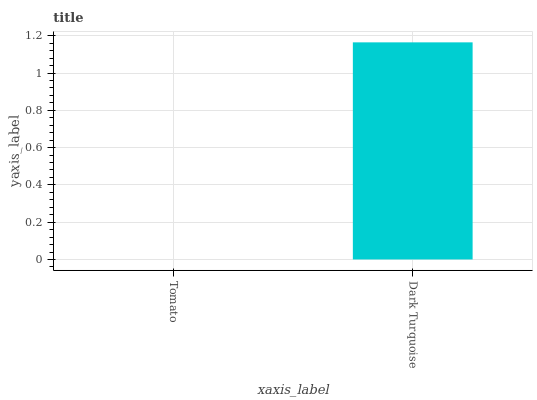Is Tomato the minimum?
Answer yes or no. Yes. Is Dark Turquoise the maximum?
Answer yes or no. Yes. Is Dark Turquoise the minimum?
Answer yes or no. No. Is Dark Turquoise greater than Tomato?
Answer yes or no. Yes. Is Tomato less than Dark Turquoise?
Answer yes or no. Yes. Is Tomato greater than Dark Turquoise?
Answer yes or no. No. Is Dark Turquoise less than Tomato?
Answer yes or no. No. Is Dark Turquoise the high median?
Answer yes or no. Yes. Is Tomato the low median?
Answer yes or no. Yes. Is Tomato the high median?
Answer yes or no. No. Is Dark Turquoise the low median?
Answer yes or no. No. 